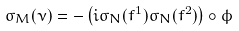<formula> <loc_0><loc_0><loc_500><loc_500>\sigma _ { M } ( \nu ) = - \left ( i \sigma _ { N } ( f ^ { 1 } ) \sigma _ { N } ( f ^ { 2 } ) \right ) \circ \phi</formula> 